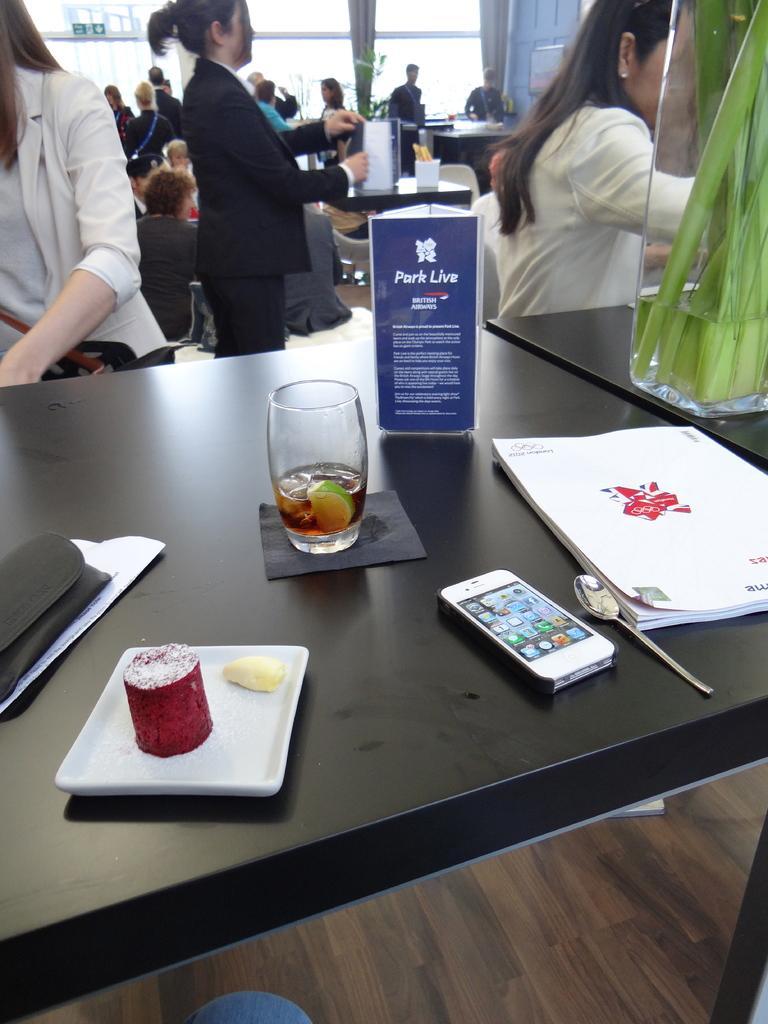Can you describe this image briefly? The black table consists of a park live brochure,book,spoon,i-phone,black purse and a drink and there are group of people sitting in the background. 